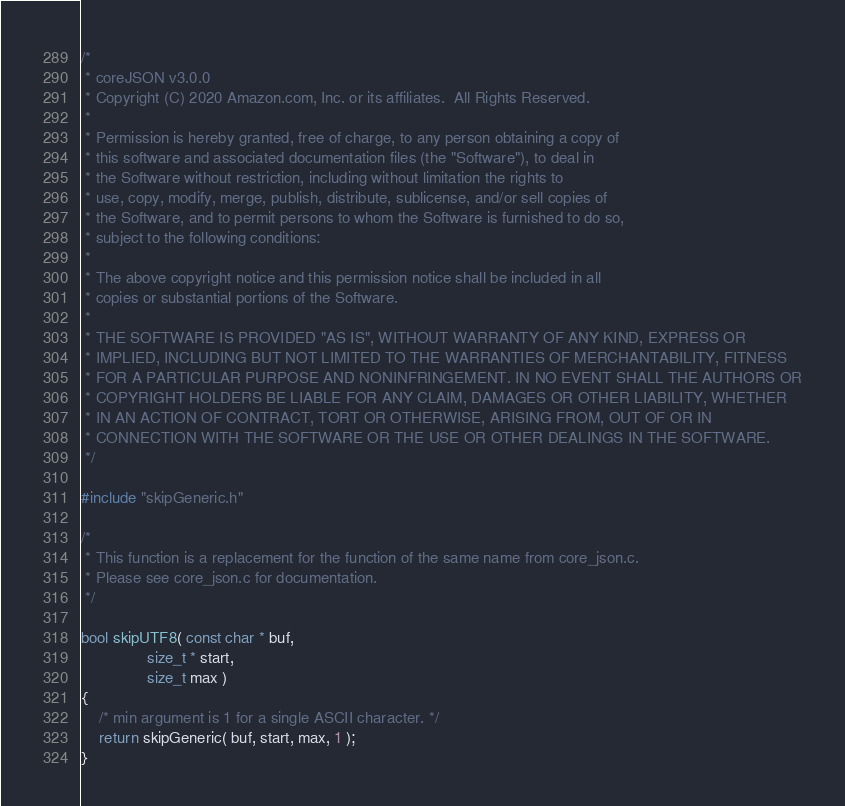<code> <loc_0><loc_0><loc_500><loc_500><_C_>/*
 * coreJSON v3.0.0
 * Copyright (C) 2020 Amazon.com, Inc. or its affiliates.  All Rights Reserved.
 *
 * Permission is hereby granted, free of charge, to any person obtaining a copy of
 * this software and associated documentation files (the "Software"), to deal in
 * the Software without restriction, including without limitation the rights to
 * use, copy, modify, merge, publish, distribute, sublicense, and/or sell copies of
 * the Software, and to permit persons to whom the Software is furnished to do so,
 * subject to the following conditions:
 *
 * The above copyright notice and this permission notice shall be included in all
 * copies or substantial portions of the Software.
 *
 * THE SOFTWARE IS PROVIDED "AS IS", WITHOUT WARRANTY OF ANY KIND, EXPRESS OR
 * IMPLIED, INCLUDING BUT NOT LIMITED TO THE WARRANTIES OF MERCHANTABILITY, FITNESS
 * FOR A PARTICULAR PURPOSE AND NONINFRINGEMENT. IN NO EVENT SHALL THE AUTHORS OR
 * COPYRIGHT HOLDERS BE LIABLE FOR ANY CLAIM, DAMAGES OR OTHER LIABILITY, WHETHER
 * IN AN ACTION OF CONTRACT, TORT OR OTHERWISE, ARISING FROM, OUT OF OR IN
 * CONNECTION WITH THE SOFTWARE OR THE USE OR OTHER DEALINGS IN THE SOFTWARE.
 */

#include "skipGeneric.h"

/*
 * This function is a replacement for the function of the same name from core_json.c.
 * Please see core_json.c for documentation.
 */

bool skipUTF8( const char * buf,
               size_t * start,
               size_t max )
{
    /* min argument is 1 for a single ASCII character. */
    return skipGeneric( buf, start, max, 1 );
}
</code> 